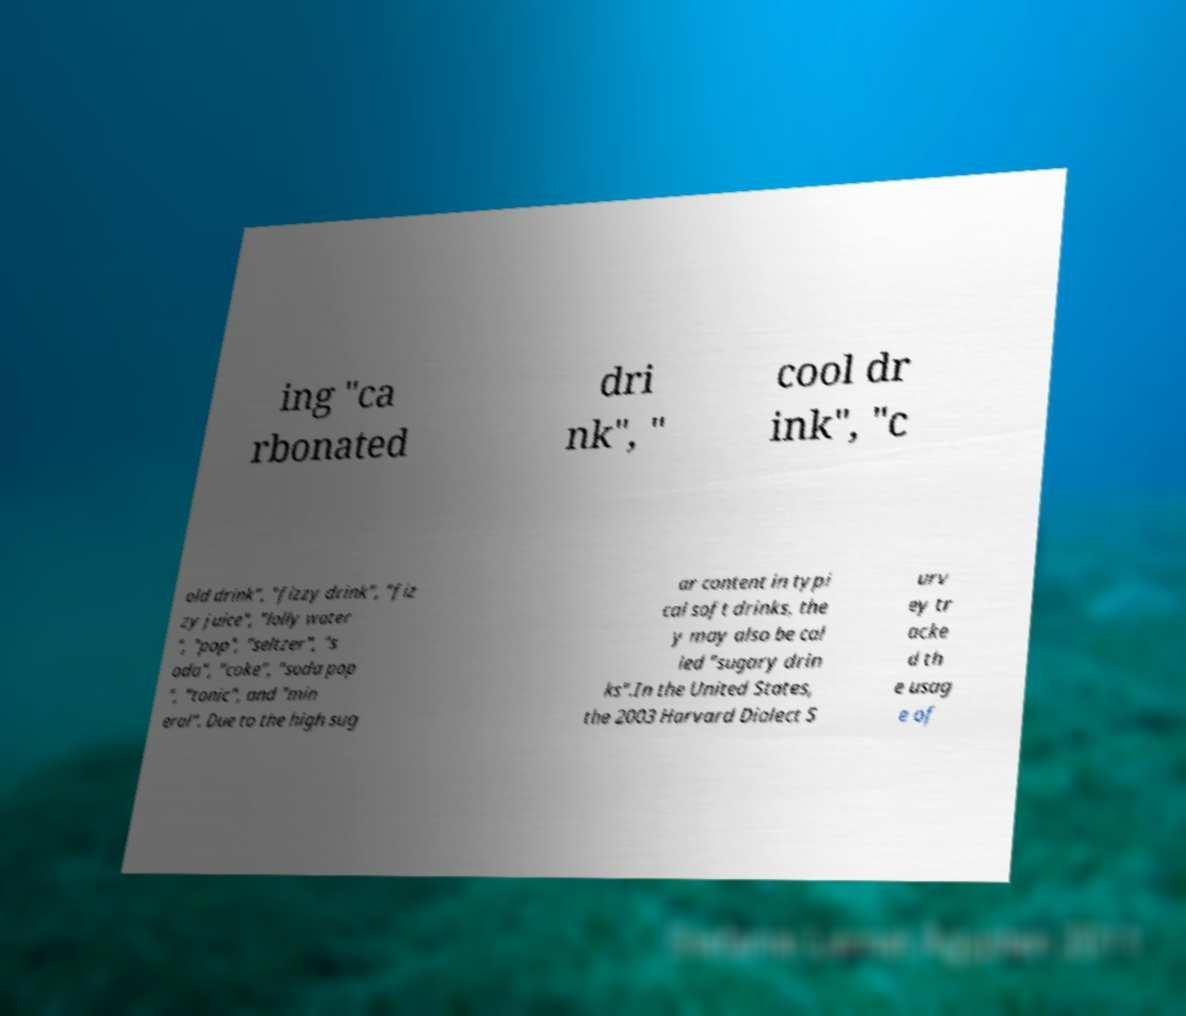Can you read and provide the text displayed in the image?This photo seems to have some interesting text. Can you extract and type it out for me? ing "ca rbonated dri nk", " cool dr ink", "c old drink", "fizzy drink", "fiz zy juice", "lolly water ", "pop", "seltzer", "s oda", "coke", "soda pop ", "tonic", and "min eral". Due to the high sug ar content in typi cal soft drinks, the y may also be cal led "sugary drin ks".In the United States, the 2003 Harvard Dialect S urv ey tr acke d th e usag e of 